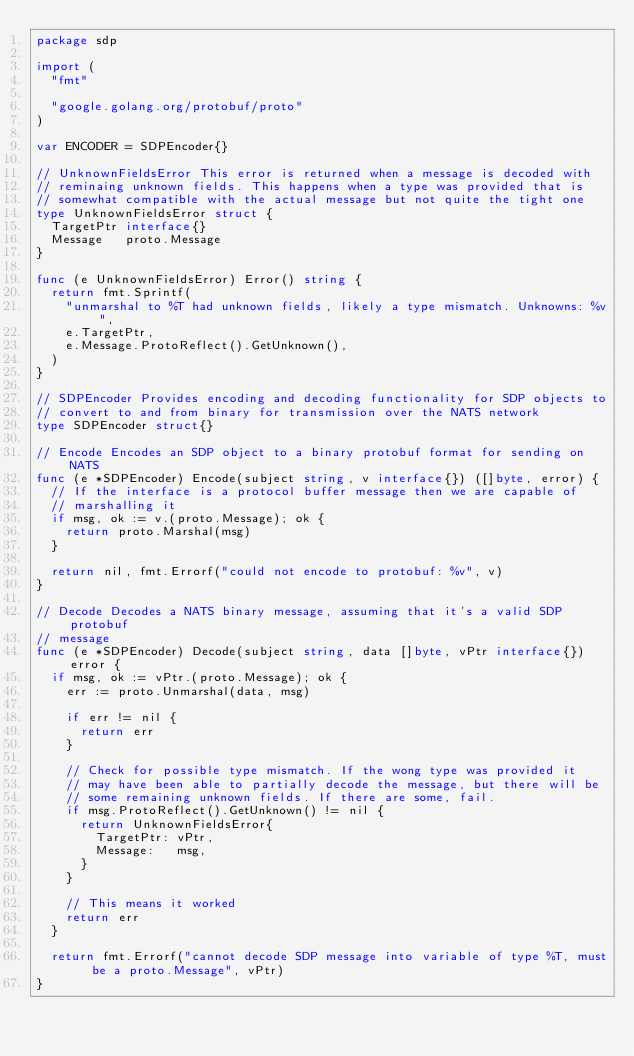Convert code to text. <code><loc_0><loc_0><loc_500><loc_500><_Go_>package sdp

import (
	"fmt"

	"google.golang.org/protobuf/proto"
)

var ENCODER = SDPEncoder{}

// UnknownFieldsError This error is returned when a message is decoded with
// reminaing unknown fields. This happens when a type was provided that is
// somewhat compatible with the actual message but not quite the tight one
type UnknownFieldsError struct {
	TargetPtr interface{}
	Message   proto.Message
}

func (e UnknownFieldsError) Error() string {
	return fmt.Sprintf(
		"unmarshal to %T had unknown fields, likely a type mismatch. Unknowns: %v",
		e.TargetPtr,
		e.Message.ProtoReflect().GetUnknown(),
	)
}

// SDPEncoder Provides encoding and decoding functionality for SDP objects to
// convert to and from binary for transmission over the NATS network
type SDPEncoder struct{}

// Encode Encodes an SDP object to a binary protobuf format for sending on NATS
func (e *SDPEncoder) Encode(subject string, v interface{}) ([]byte, error) {
	// If the interface is a protocol buffer message then we are capable of
	// marshalling it
	if msg, ok := v.(proto.Message); ok {
		return proto.Marshal(msg)
	}

	return nil, fmt.Errorf("could not encode to protobuf: %v", v)
}

// Decode Decodes a NATS binary message, assuming that it's a valid SDP protobuf
// message
func (e *SDPEncoder) Decode(subject string, data []byte, vPtr interface{}) error {
	if msg, ok := vPtr.(proto.Message); ok {
		err := proto.Unmarshal(data, msg)

		if err != nil {
			return err
		}

		// Check for possible type mismatch. If the wong type was provided it
		// may have been able to partially decode the message, but there will be
		// some remaining unknown fields. If there are some, fail.
		if msg.ProtoReflect().GetUnknown() != nil {
			return UnknownFieldsError{
				TargetPtr: vPtr,
				Message:   msg,
			}
		}

		// This means it worked
		return err
	}

	return fmt.Errorf("cannot decode SDP message into variable of type %T, must be a proto.Message", vPtr)
}
</code> 